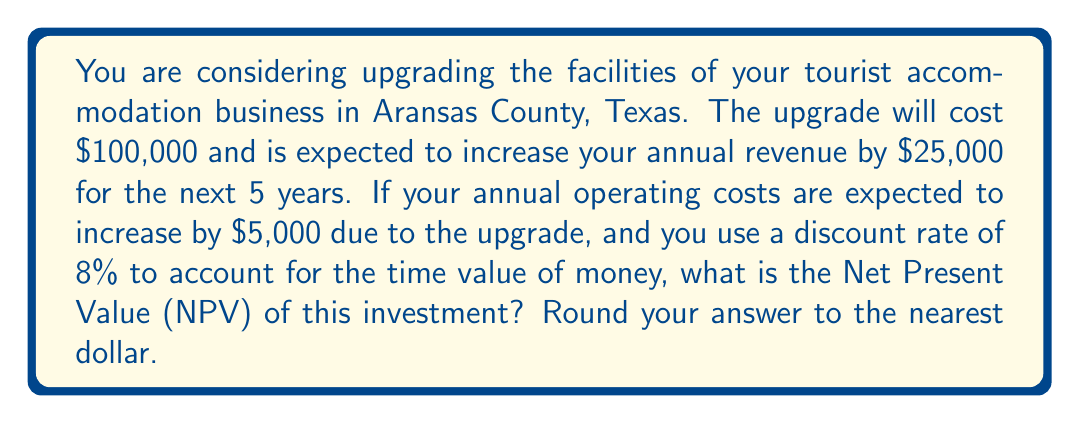Show me your answer to this math problem. To solve this problem, we need to calculate the Net Present Value (NPV) of the investment. The NPV is the difference between the present value of cash inflows and the present value of cash outflows over a period of time. Let's break it down step by step:

1. Initial investment: $100,000

2. Annual net cash flow:
   Increase in revenue: $25,000
   Increase in operating costs: $5,000
   Net annual cash flow: $25,000 - $5,000 = $20,000

3. Calculate the present value of the cash flows for each year:
   Present Value = Future Value / (1 + r)^t
   Where r is the discount rate (8% or 0.08) and t is the year

   Year 1: $20,000 / (1 + 0.08)^1 = $18,518.52
   Year 2: $20,000 / (1 + 0.08)^2 = $17,146.78
   Year 3: $20,000 / (1 + 0.08)^3 = $15,876.65
   Year 4: $20,000 / (1 + 0.08)^4 = $14,700.60
   Year 5: $20,000 / (1 + 0.08)^5 = $13,611.67

4. Sum up the present values:
   Total Present Value = $18,518.52 + $17,146.78 + $15,876.65 + $14,700.60 + $13,611.67
                       = $79,854.22

5. Calculate the NPV:
   NPV = Total Present Value - Initial Investment
       = $79,854.22 - $100,000
       = -$20,145.78

6. Round to the nearest dollar:
   NPV ≈ -$20,146

The negative NPV indicates that the investment is not financially viable based on the given parameters and discount rate.
Answer: The Net Present Value (NPV) of the investment is approximately -$20,146. 